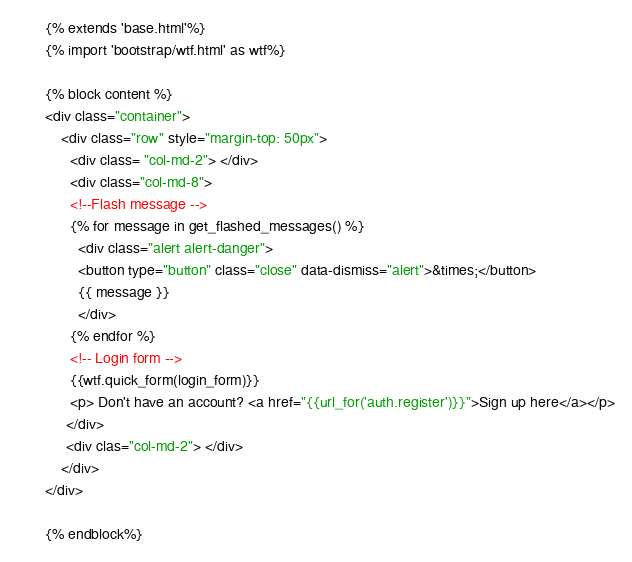<code> <loc_0><loc_0><loc_500><loc_500><_HTML_>{% extends 'base.html'%}
{% import 'bootstrap/wtf.html' as wtf%}

{% block content %}
<div class="container">
    <div class="row" style="margin-top: 50px">
      <div class= "col-md-2"> </div>
      <div class="col-md-8">
      <!--Flash message -->
      {% for message in get_flashed_messages() %}
        <div class="alert alert-danger">
        <button type="button" class="close" data-dismiss="alert">&times;</button>
        {{ message }}
        </div>
      {% endfor %}
      <!-- Login form -->
      {{wtf.quick_form(login_form)}}
      <p> Don't have an account? <a href="{{url_for('auth.register')}}">Sign up here</a></p>
     </div>
     <div clas="col-md-2"> </div>
    </div>
</div>

{% endblock%}
</code> 